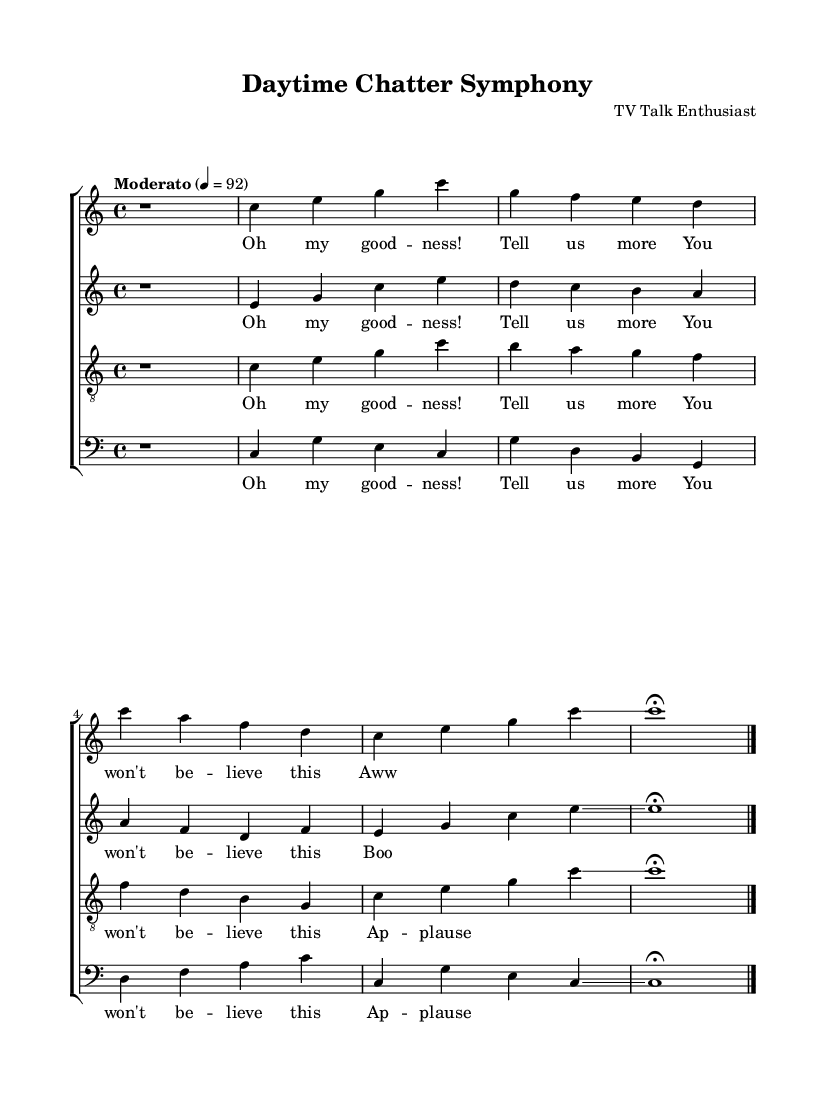What is the key signature of this music? The key signature is indicated at the beginning of the score. It is C major, which has no sharps or flats.
Answer: C major What is the time signature of the piece? The time signature is displayed after the key signature. In this case, it is 4/4, which means there are four beats in each measure.
Answer: 4/4 What is the tempo marking for this piece? The tempo marking is written at the beginning of the score. Here it is indicated as "Moderato" with a metronomic value of 92, suggesting a moderate pace.
Answer: Moderato How many voices are present in the composition? The score shows four distinct voices: soprano, alto, tenor, and bass. Each is written on a separate staff.
Answer: Four What repeated phrase appears in all voice lyrics? By examining the lyrics assigned to each vocal part, the phrase "Oh my goodness!" is present in all voices, indicating a shared thematic element.
Answer: "Oh my goodness!" Which vocal part has the glissando in the chorus? Glissando is a term for a smooth sliding from one note to another. In this music, both soprano and alto parts have a glissando that connects notes in the chorus section.
Answer: Soprano and Alto What type of musical piece is this? This piece is categorized as an experimental composition due to its use of abstract vocal collages and the conversational snippets drawn from talk show interviews.
Answer: Experimental 